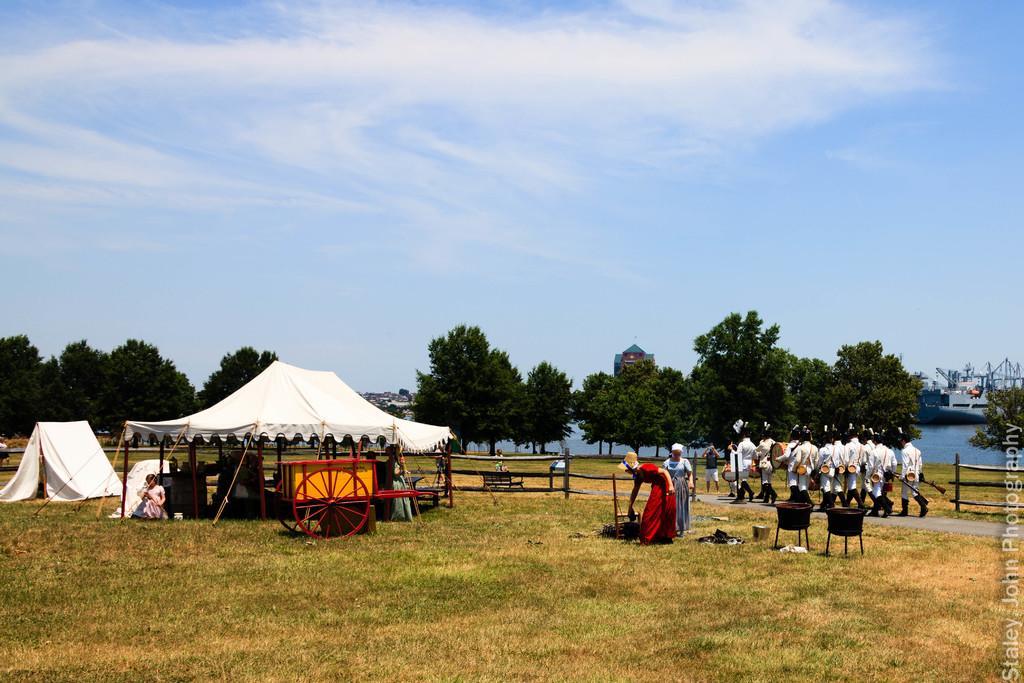Can you describe this image briefly? In this picture we can see some people are walking on the road, side we can see tent and some people are on the grass, around we can see trees and houses. 